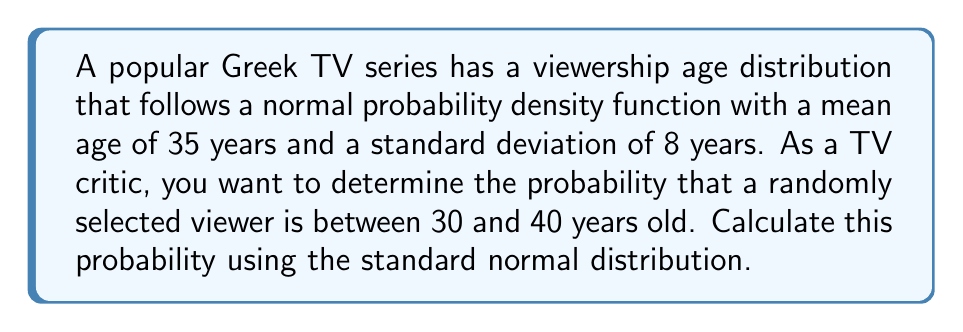Teach me how to tackle this problem. To solve this problem, we'll follow these steps:

1) First, we need to standardize the given values. The z-score formula is:

   $$ z = \frac{x - \mu}{\sigma} $$

   where $x$ is the value, $\mu$ is the mean, and $\sigma$ is the standard deviation.

2) For the lower bound (30 years):

   $$ z_1 = \frac{30 - 35}{8} = -0.625 $$

3) For the upper bound (40 years):

   $$ z_2 = \frac{40 - 35}{8} = 0.625 $$

4) Now, we need to find the area under the standard normal curve between these two z-scores. This is equivalent to:

   $$ P(-0.625 < Z < 0.625) = P(Z < 0.625) - P(Z < -0.625) $$

5) Using a standard normal distribution table or calculator:

   $P(Z < 0.625) \approx 0.7340$
   $P(Z < -0.625) \approx 0.2660$

6) Therefore, the probability is:

   $$ 0.7340 - 0.2660 = 0.4680 $$
Answer: 0.4680 